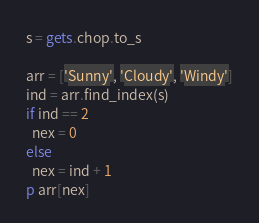Convert code to text. <code><loc_0><loc_0><loc_500><loc_500><_Ruby_>s = gets.chop.to_s

arr = ['Sunny', 'Cloudy', 'Windy']
ind = arr.find_index(s)
if ind == 2
  nex = 0
else
  nex = ind + 1
p arr[nex]</code> 